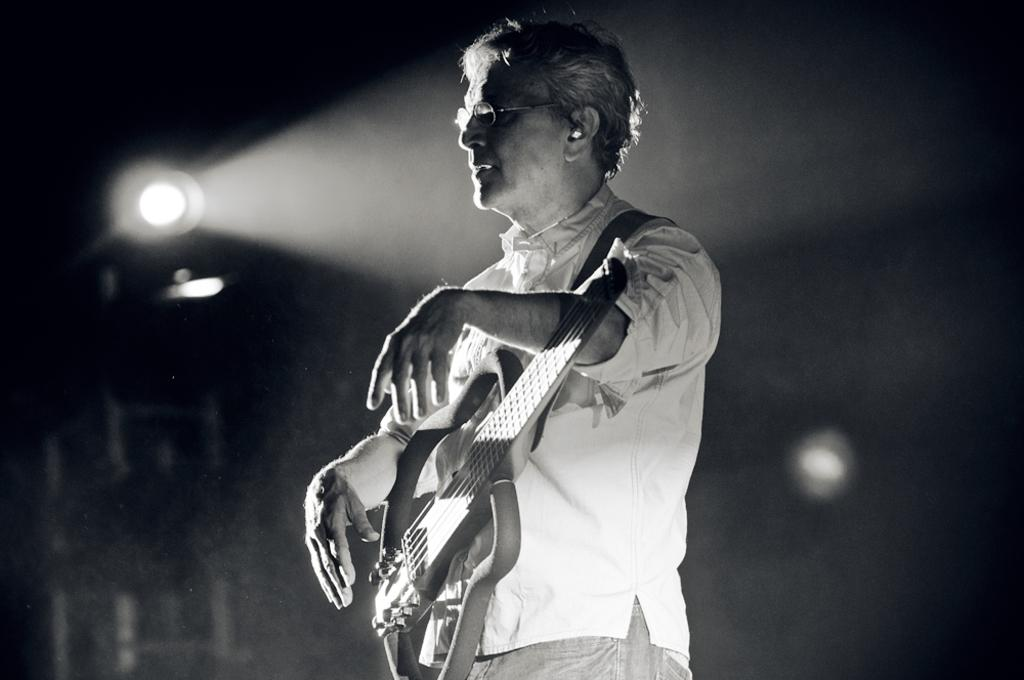What is the man in the image holding? The man is holding a guitar. What accessory is the man wearing in the image? The man is wearing spectacles. Can you describe the background of the image? There is a light in the background of the image. What type of base is supporting the guitar in the image? There is no base visible in the image; the guitar is being held by the man. 